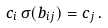<formula> <loc_0><loc_0><loc_500><loc_500>c _ { i } \, \sigma ( b _ { i j } ) = c _ { j } \, .</formula> 